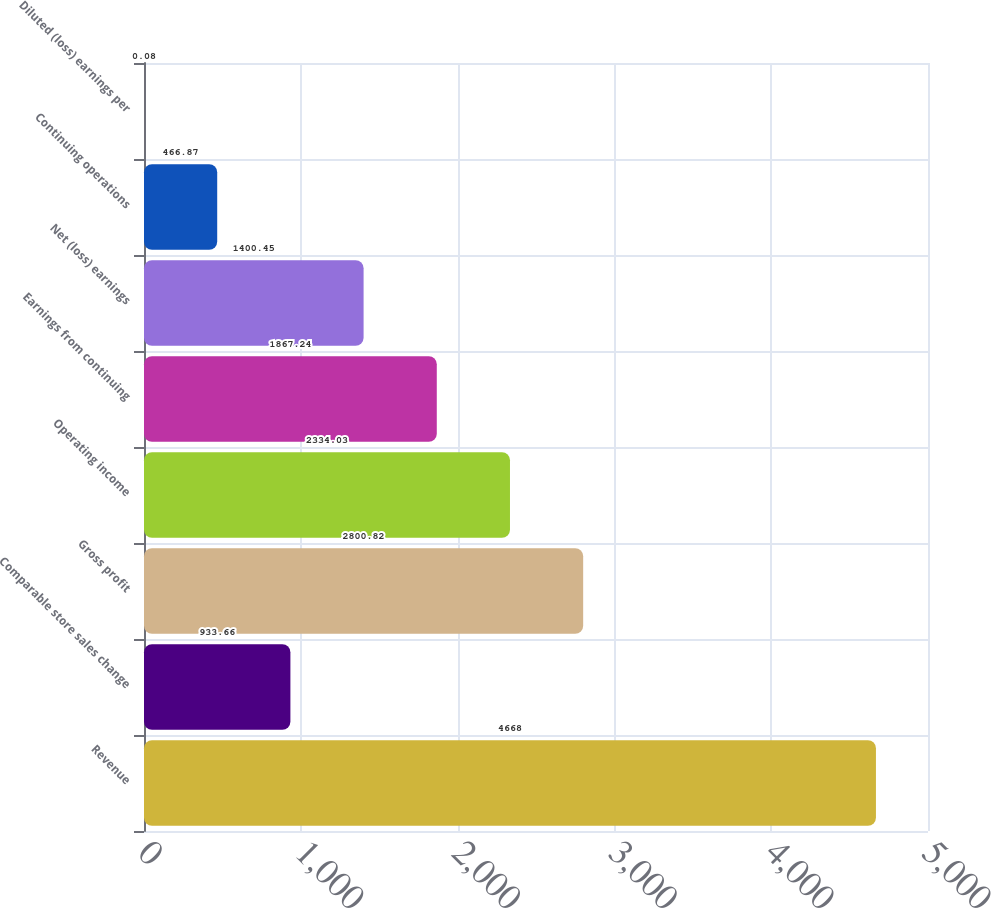<chart> <loc_0><loc_0><loc_500><loc_500><bar_chart><fcel>Revenue<fcel>Comparable store sales change<fcel>Gross profit<fcel>Operating income<fcel>Earnings from continuing<fcel>Net (loss) earnings<fcel>Continuing operations<fcel>Diluted (loss) earnings per<nl><fcel>4668<fcel>933.66<fcel>2800.82<fcel>2334.03<fcel>1867.24<fcel>1400.45<fcel>466.87<fcel>0.08<nl></chart> 